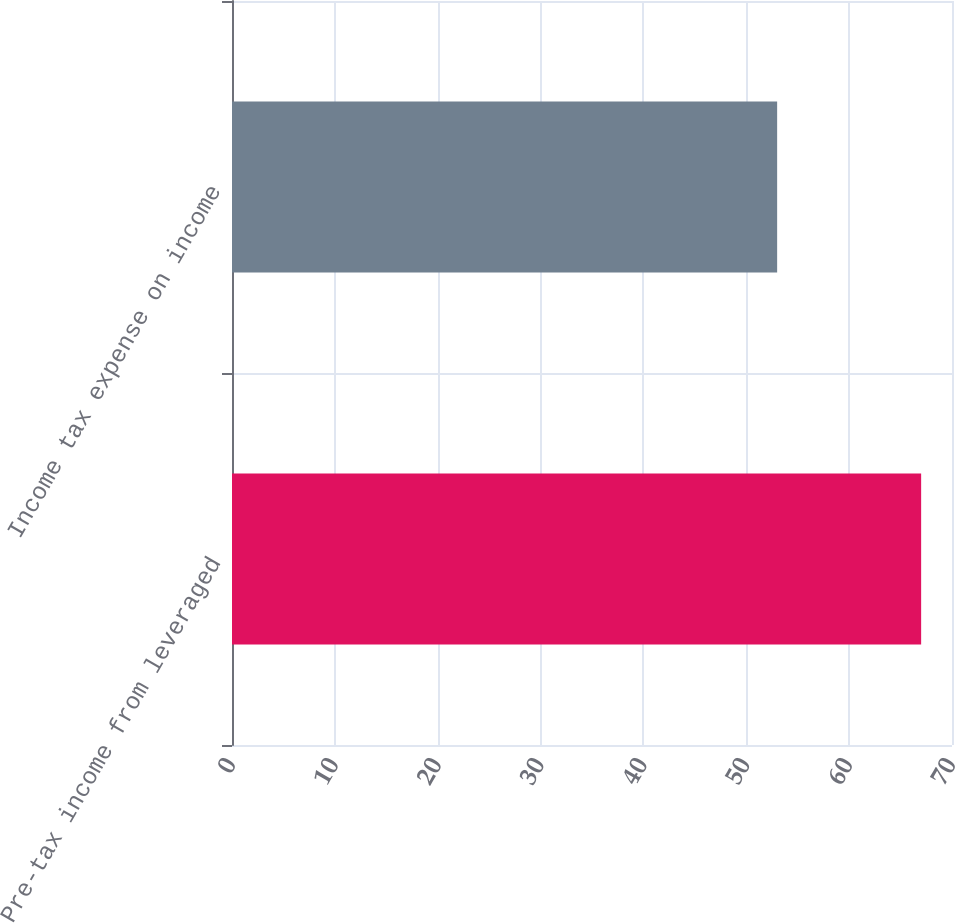<chart> <loc_0><loc_0><loc_500><loc_500><bar_chart><fcel>Pre-tax income from leveraged<fcel>Income tax expense on income<nl><fcel>67<fcel>53<nl></chart> 